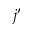<formula> <loc_0><loc_0><loc_500><loc_500>j ^ { \prime }</formula> 